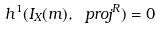<formula> <loc_0><loc_0><loc_500><loc_500>h ^ { 1 } ( I _ { X } ( m ) , \ p r o j ^ { R } ) = 0</formula> 